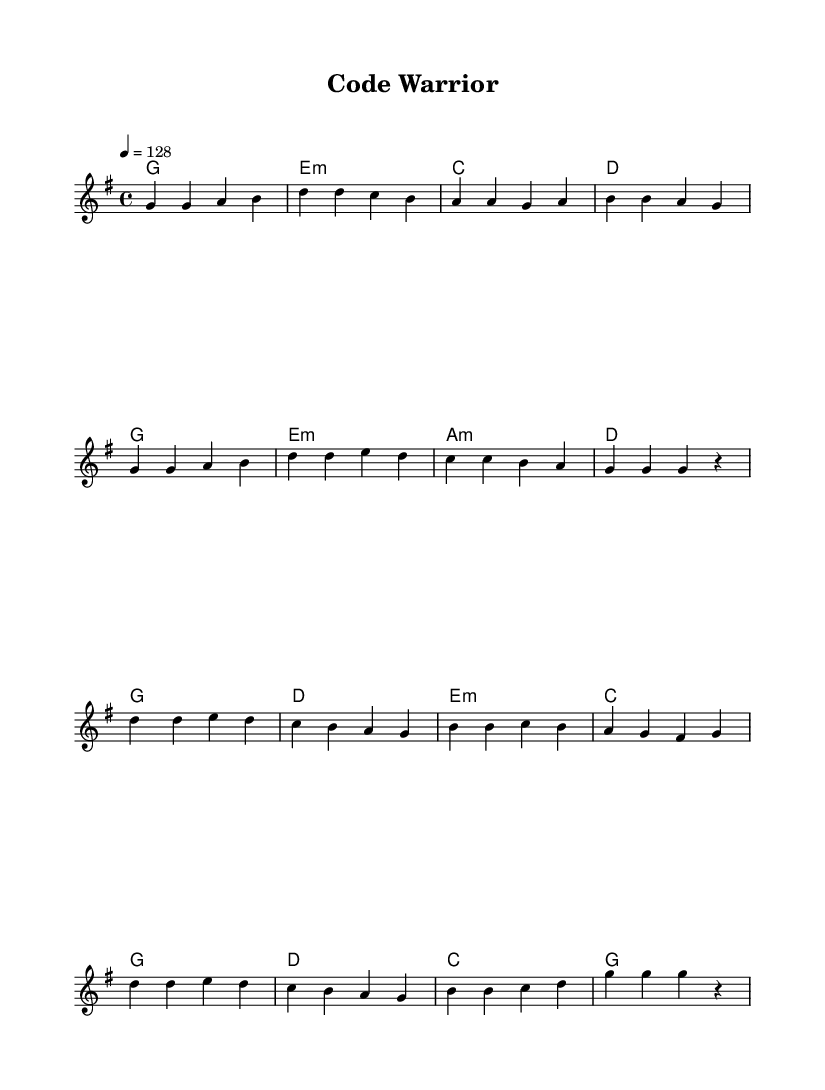What is the key signature of this music? The key signature displayed is one sharp, indicating G major.
Answer: G major What is the time signature of the piece? The time signature is indicated at the beginning as 4/4, meaning there are four beats in each measure.
Answer: 4/4 What is the tempo marking of this track? The tempo marking shows a speed of 128 beats per minute, which is typically upbeat and energetic.
Answer: 128 How many measures are in the verse section? By counting the measures notated in the 'Verse' section, there are eight measures.
Answer: 8 What is the difference in chord progression between the verse and chorus? In the verse, the chords cycle through G, E minor, C, and D, while in the chorus, the chords progress through G, D, E minor, and C.
Answer: Different chord sequences What is a characteristic feature of K-Pop music evident in this piece? This piece features energetic melodies and repetitive structures, which are common in K-Pop tracks designed to keep listeners engaged during activities like workouts.
Answer: Energetic melodies 